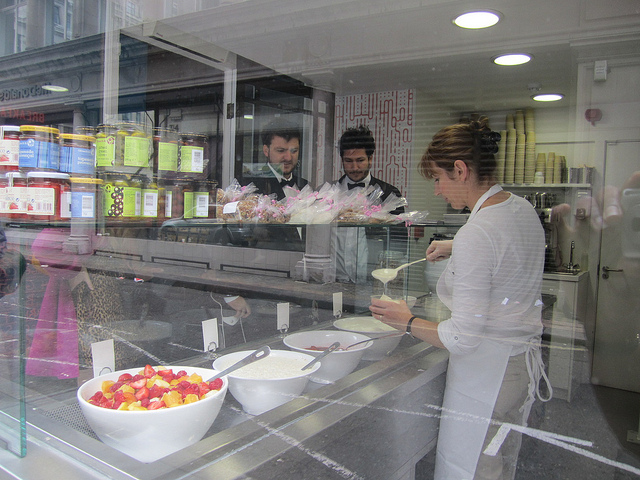How many people are there? 3 